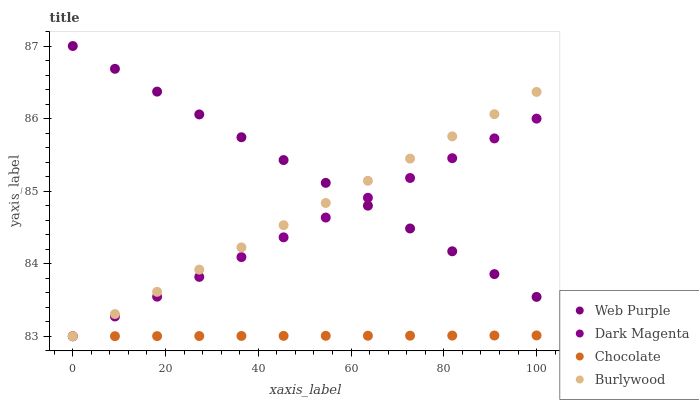Does Chocolate have the minimum area under the curve?
Answer yes or no. Yes. Does Web Purple have the maximum area under the curve?
Answer yes or no. Yes. Does Dark Magenta have the minimum area under the curve?
Answer yes or no. No. Does Dark Magenta have the maximum area under the curve?
Answer yes or no. No. Is Chocolate the smoothest?
Answer yes or no. Yes. Is Burlywood the roughest?
Answer yes or no. Yes. Is Web Purple the smoothest?
Answer yes or no. No. Is Web Purple the roughest?
Answer yes or no. No. Does Burlywood have the lowest value?
Answer yes or no. Yes. Does Web Purple have the lowest value?
Answer yes or no. No. Does Web Purple have the highest value?
Answer yes or no. Yes. Does Dark Magenta have the highest value?
Answer yes or no. No. Is Chocolate less than Web Purple?
Answer yes or no. Yes. Is Web Purple greater than Chocolate?
Answer yes or no. Yes. Does Burlywood intersect Chocolate?
Answer yes or no. Yes. Is Burlywood less than Chocolate?
Answer yes or no. No. Is Burlywood greater than Chocolate?
Answer yes or no. No. Does Chocolate intersect Web Purple?
Answer yes or no. No. 